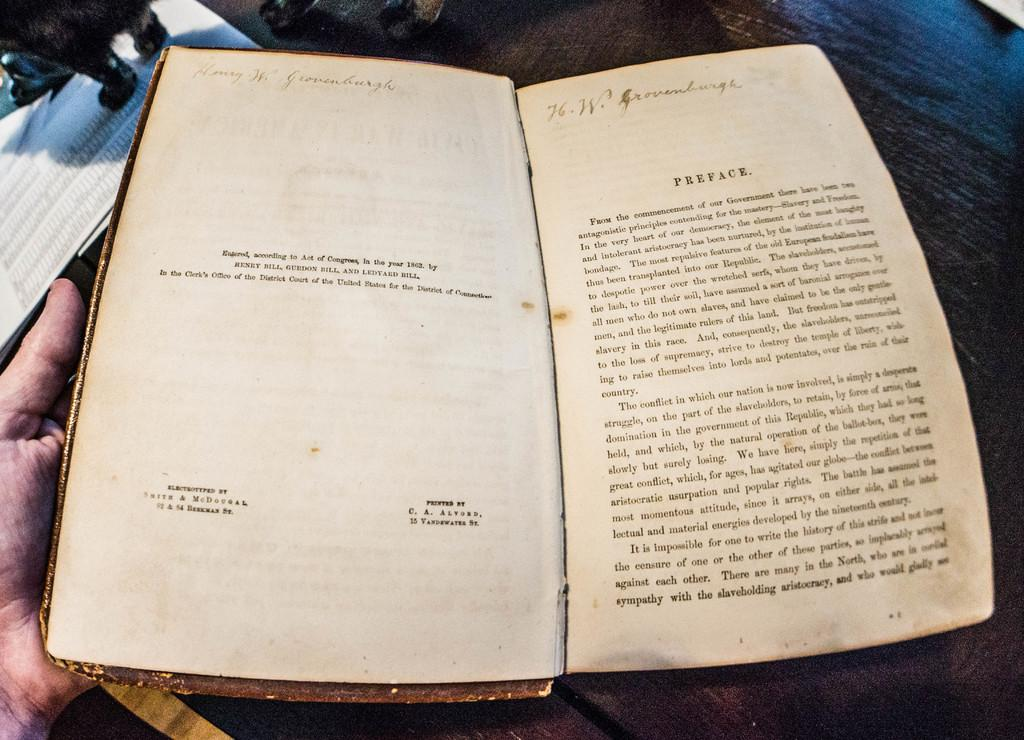<image>
Share a concise interpretation of the image provided. An old worn out book with the word "Preface" printed at the top of the page. 